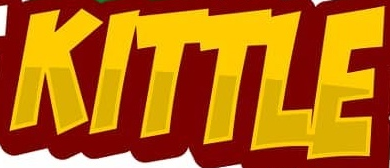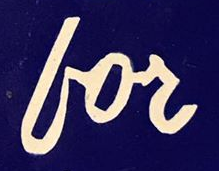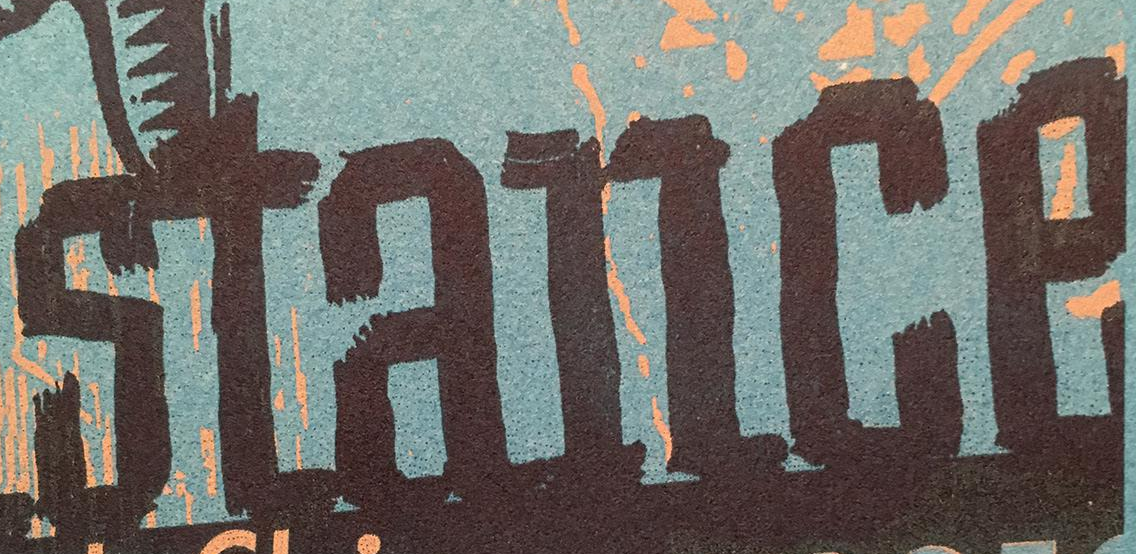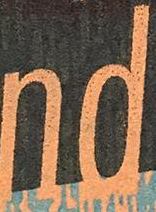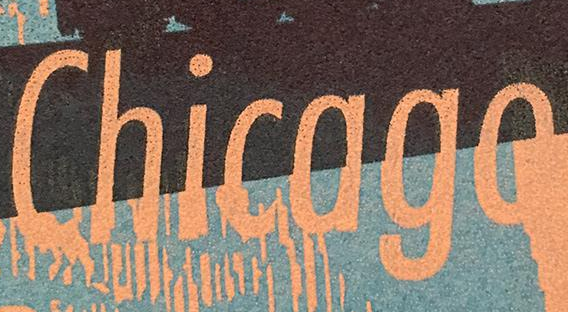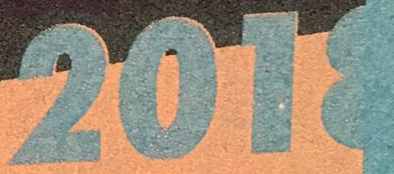What words can you see in these images in sequence, separated by a semicolon? KITTLE; for; stance; nd; Chicago; 2018 